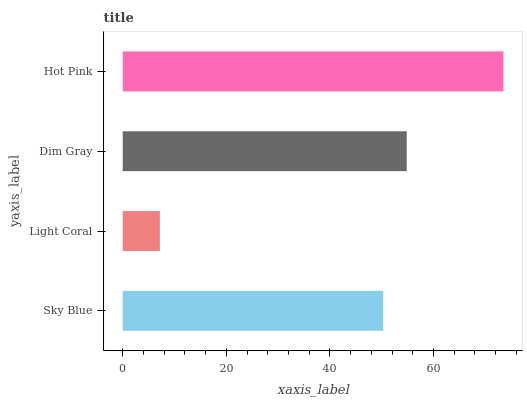Is Light Coral the minimum?
Answer yes or no. Yes. Is Hot Pink the maximum?
Answer yes or no. Yes. Is Dim Gray the minimum?
Answer yes or no. No. Is Dim Gray the maximum?
Answer yes or no. No. Is Dim Gray greater than Light Coral?
Answer yes or no. Yes. Is Light Coral less than Dim Gray?
Answer yes or no. Yes. Is Light Coral greater than Dim Gray?
Answer yes or no. No. Is Dim Gray less than Light Coral?
Answer yes or no. No. Is Dim Gray the high median?
Answer yes or no. Yes. Is Sky Blue the low median?
Answer yes or no. Yes. Is Light Coral the high median?
Answer yes or no. No. Is Light Coral the low median?
Answer yes or no. No. 